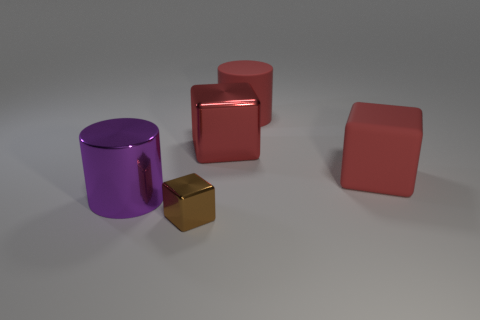Are there any brown shiny things behind the tiny brown cube?
Keep it short and to the point. No. What shape is the purple metallic object?
Provide a short and direct response. Cylinder. What number of things are things right of the purple thing or red spheres?
Your response must be concise. 4. What number of other objects are there of the same color as the rubber cylinder?
Provide a short and direct response. 2. There is a large matte cylinder; is its color the same as the big shiny thing that is behind the purple thing?
Give a very brief answer. Yes. The small metal object that is the same shape as the large red metal object is what color?
Provide a short and direct response. Brown. Does the brown thing have the same material as the big object left of the tiny brown object?
Your answer should be compact. Yes. What color is the rubber cylinder?
Make the answer very short. Red. What is the color of the large cylinder that is in front of the cylinder that is behind the shiny thing that is left of the brown metal thing?
Make the answer very short. Purple. Does the brown thing have the same shape as the large shiny thing on the right side of the tiny brown metallic object?
Your answer should be compact. Yes. 